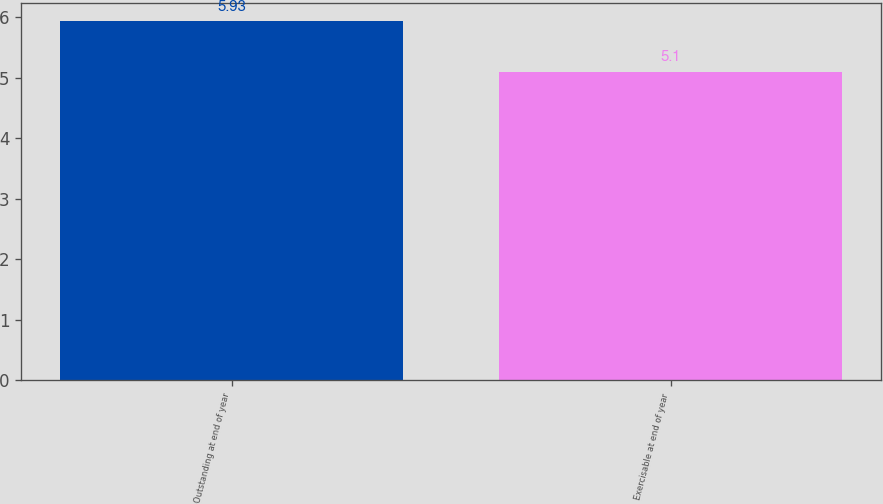<chart> <loc_0><loc_0><loc_500><loc_500><bar_chart><fcel>Outstanding at end of year<fcel>Exercisable at end of year<nl><fcel>5.93<fcel>5.1<nl></chart> 